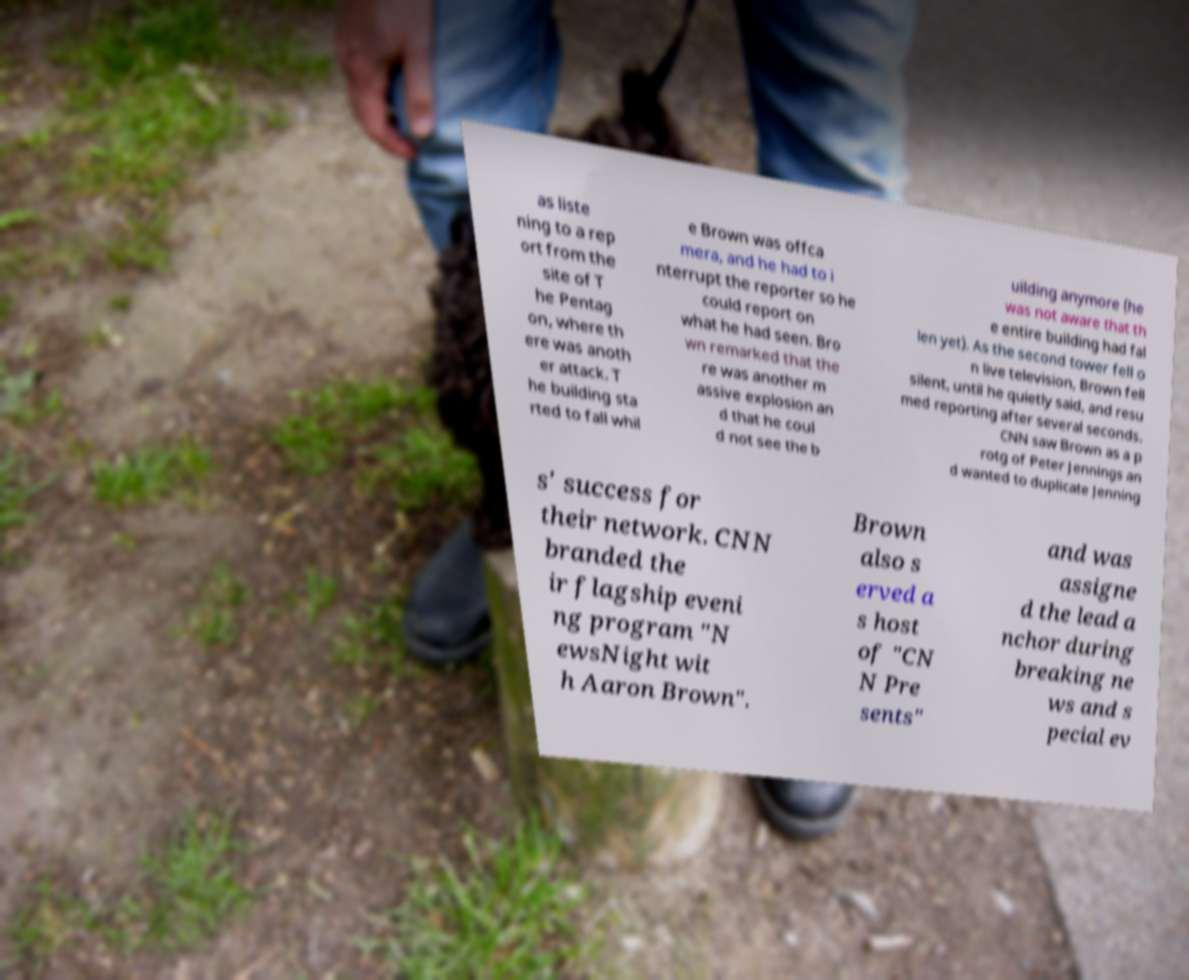Please identify and transcribe the text found in this image. as liste ning to a rep ort from the site of T he Pentag on, where th ere was anoth er attack. T he building sta rted to fall whil e Brown was offca mera, and he had to i nterrupt the reporter so he could report on what he had seen. Bro wn remarked that the re was another m assive explosion an d that he coul d not see the b uilding anymore (he was not aware that th e entire building had fal len yet). As the second tower fell o n live television, Brown fell silent, until he quietly said, and resu med reporting after several seconds. CNN saw Brown as a p rotg of Peter Jennings an d wanted to duplicate Jenning s' success for their network. CNN branded the ir flagship eveni ng program "N ewsNight wit h Aaron Brown". Brown also s erved a s host of "CN N Pre sents" and was assigne d the lead a nchor during breaking ne ws and s pecial ev 